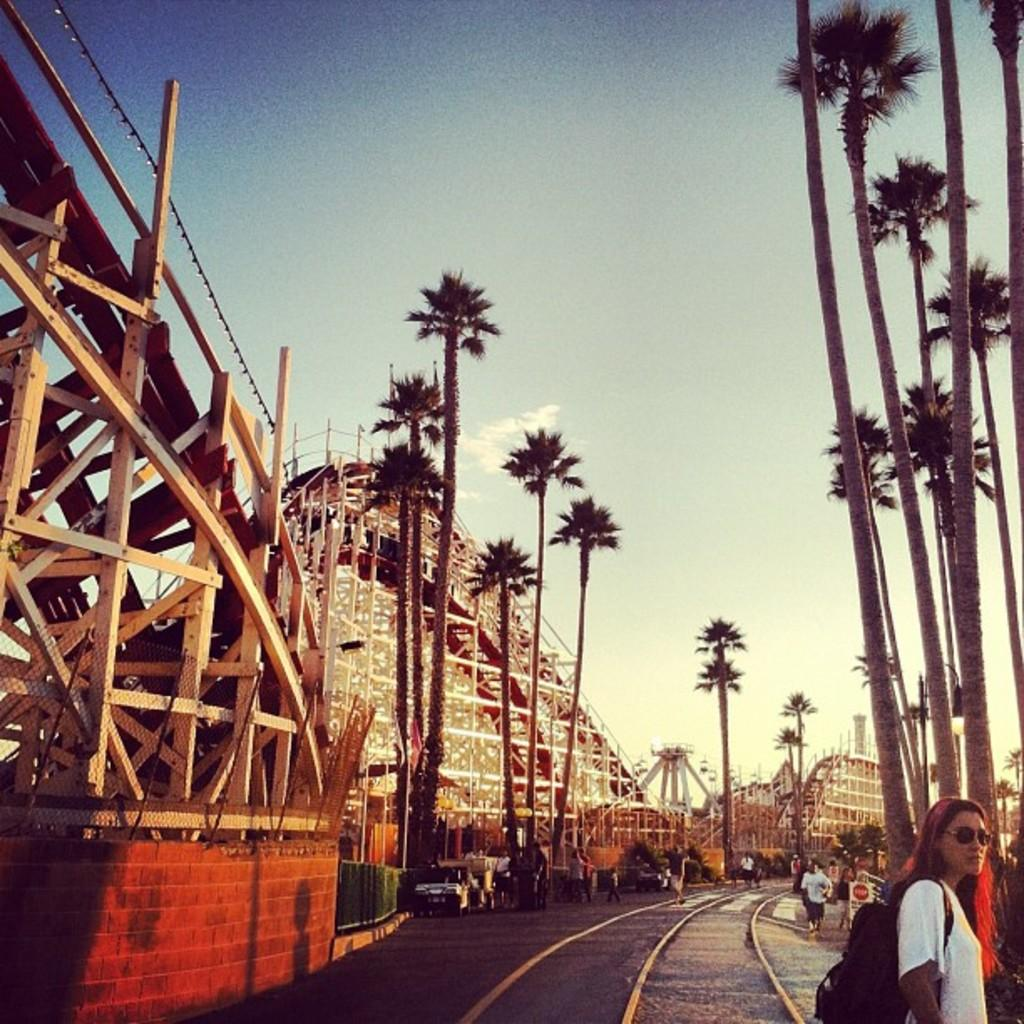What structures can be seen in the image? There are towers in the image. What type of vegetation is present in the image? There are trees in the image. What part of the natural environment is visible in the image? The sky is visible in the image. What type of transportation infrastructure is present in the image? There is a road and a railway track on the road in the image. What is moving on the road in the image? Vehicles are present on the road, and people are walking on the road. Who is the owner of the arm visible in the image? There is no arm visible in the image. What type of smoke can be seen coming from the towers in the image? There is no smoke coming from the towers in the image. 